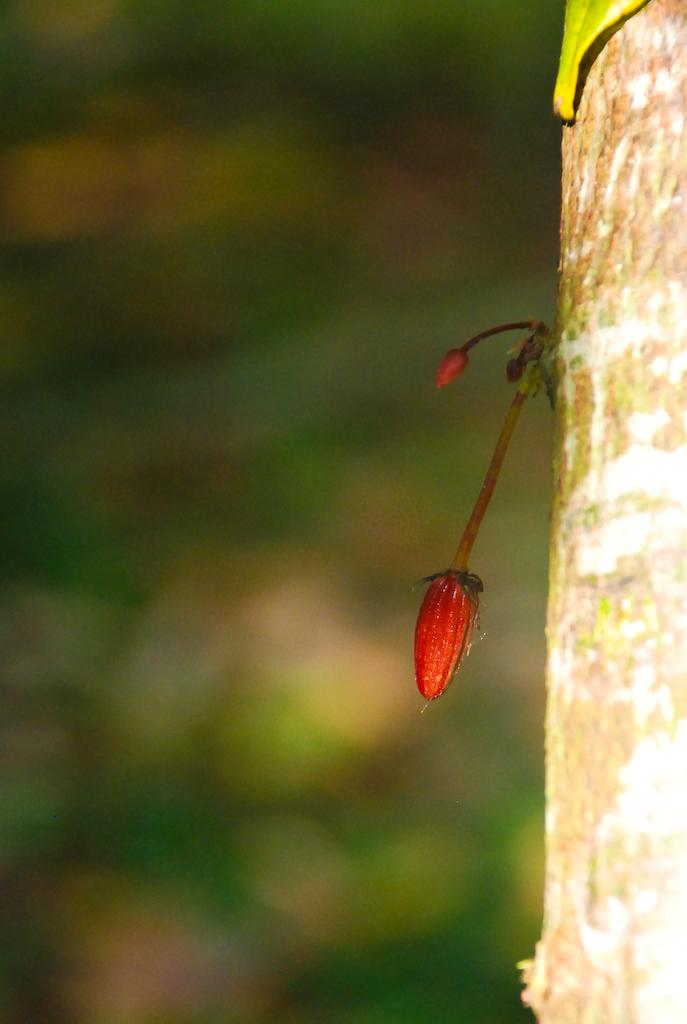What can be seen growing on the tree trunk in the image? There is a bud and a leaf on the tree trunk in the image. How would you describe the background of the image? The background of the image is blurry. How many apples are hanging from the tree trunk in the image? There are no apples present in the image; it only features a bud and a leaf on the tree trunk. 